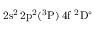<formula> <loc_0><loc_0><loc_500><loc_500>2 s ^ { 2 } \, 2 p ^ { 2 } ( ^ { 3 } P ) \, 4 f ^ { 2 } D ^ { \circ }</formula> 